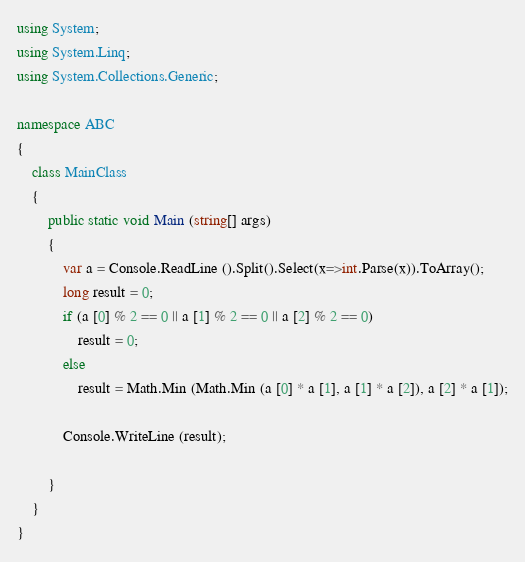<code> <loc_0><loc_0><loc_500><loc_500><_C#_>using System;
using System.Linq;
using System.Collections.Generic;

namespace ABC
{
	class MainClass
	{
		public static void Main (string[] args)
		{
			var a = Console.ReadLine ().Split().Select(x=>int.Parse(x)).ToArray();
			long result = 0;
			if (a [0] % 2 == 0 || a [1] % 2 == 0 || a [2] % 2 == 0)
				result = 0;
			else
				result = Math.Min (Math.Min (a [0] * a [1], a [1] * a [2]), a [2] * a [1]);

			Console.WriteLine (result);
				
		}
	}
}
</code> 